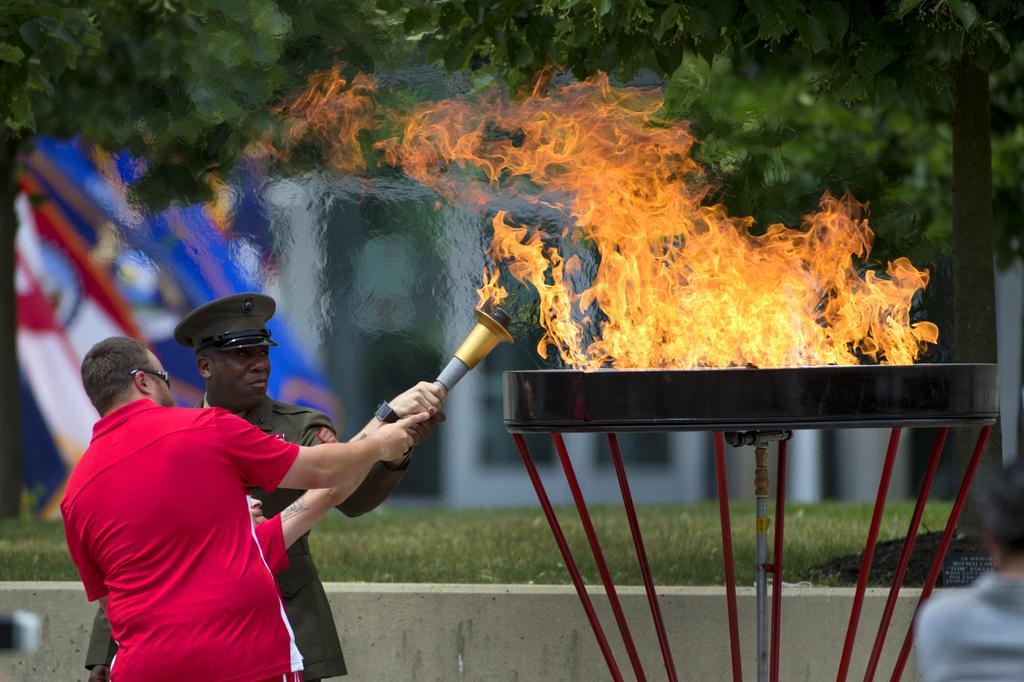Please provide a concise description of this image. In this image I can see two men are standing on the left side and I can see both of them are holding a fire stick. On the right side of this image I can see a stand and on it I can see fire. In the background I can see few trees and grass and I can see this image is little bit blurry in the background. On the right bottom side of this image I can see a board and on it I can see something is written. I can also see a blue and white color thing on the left side of this image. 